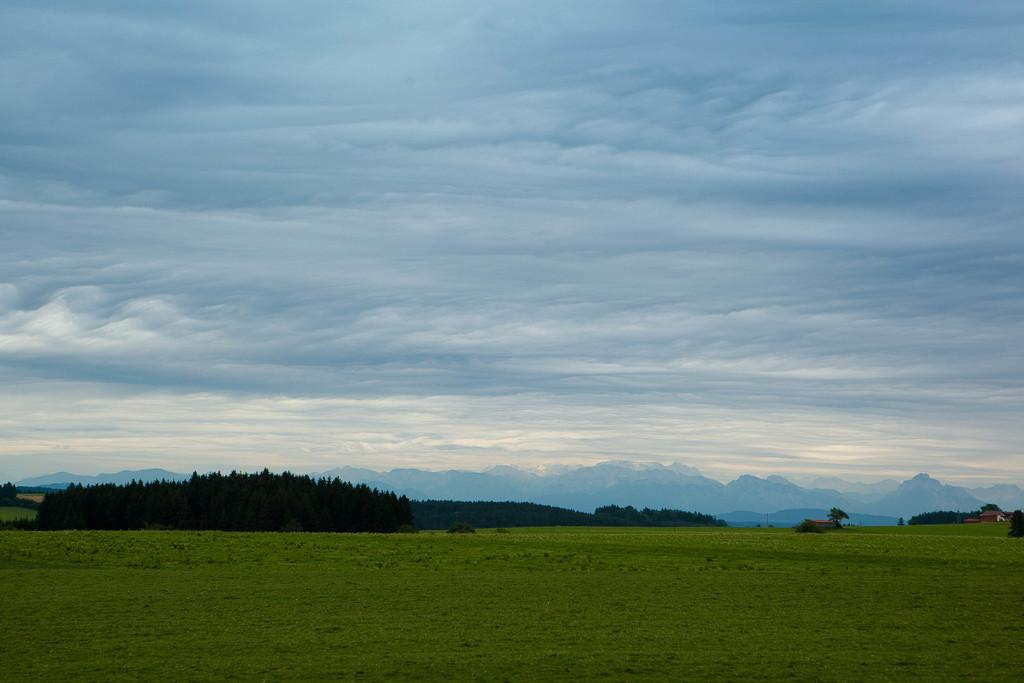What type of vegetation can be seen in the image? There is grass, a group of trees, and plants in the image. What type of structures are visible in the image? There are houses in the image. What natural landmarks can be seen in the image? The mountains are visible in the image. What is the condition of the sky in the image? The sky is cloudy in the image. What type of boot can be seen hanging from the trees in the image? There is no boot hanging from the trees in the image; only grass, trees, plants, houses, mountains, and a cloudy sky are present. What type of copper structure is visible in the image? There is no copper structure present in the image. 